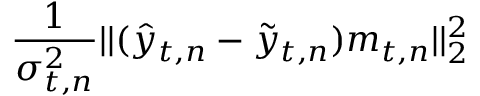<formula> <loc_0><loc_0><loc_500><loc_500>\frac { 1 } { \sigma _ { t , n } ^ { 2 } } | | ( \hat { y } _ { t , n } - \tilde { y } _ { t , n } ) m _ { t , n } | | _ { 2 } ^ { 2 }</formula> 